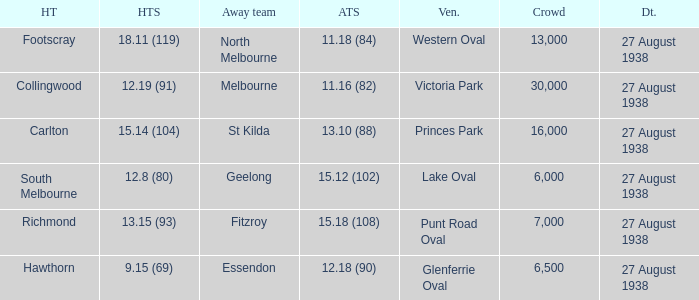What is the average crowd attendance for Collingwood? 30000.0. 